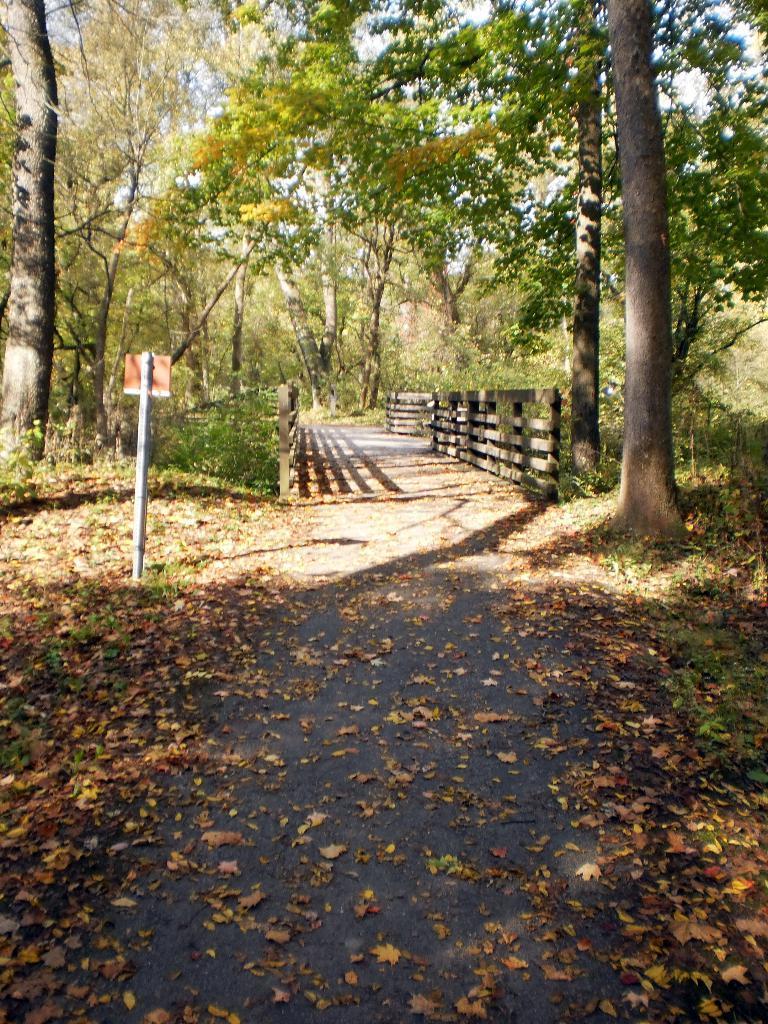Please provide a concise description of this image. In the center of the image we can see the sky, trees, grass, dry leaves, fences, walkway and one pole with a board 